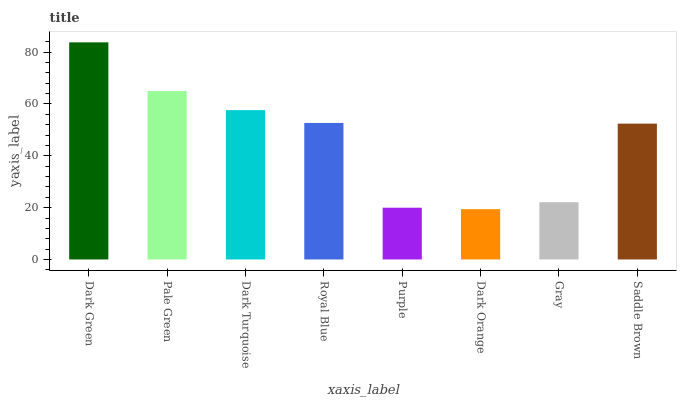Is Dark Orange the minimum?
Answer yes or no. Yes. Is Dark Green the maximum?
Answer yes or no. Yes. Is Pale Green the minimum?
Answer yes or no. No. Is Pale Green the maximum?
Answer yes or no. No. Is Dark Green greater than Pale Green?
Answer yes or no. Yes. Is Pale Green less than Dark Green?
Answer yes or no. Yes. Is Pale Green greater than Dark Green?
Answer yes or no. No. Is Dark Green less than Pale Green?
Answer yes or no. No. Is Royal Blue the high median?
Answer yes or no. Yes. Is Saddle Brown the low median?
Answer yes or no. Yes. Is Dark Orange the high median?
Answer yes or no. No. Is Dark Orange the low median?
Answer yes or no. No. 